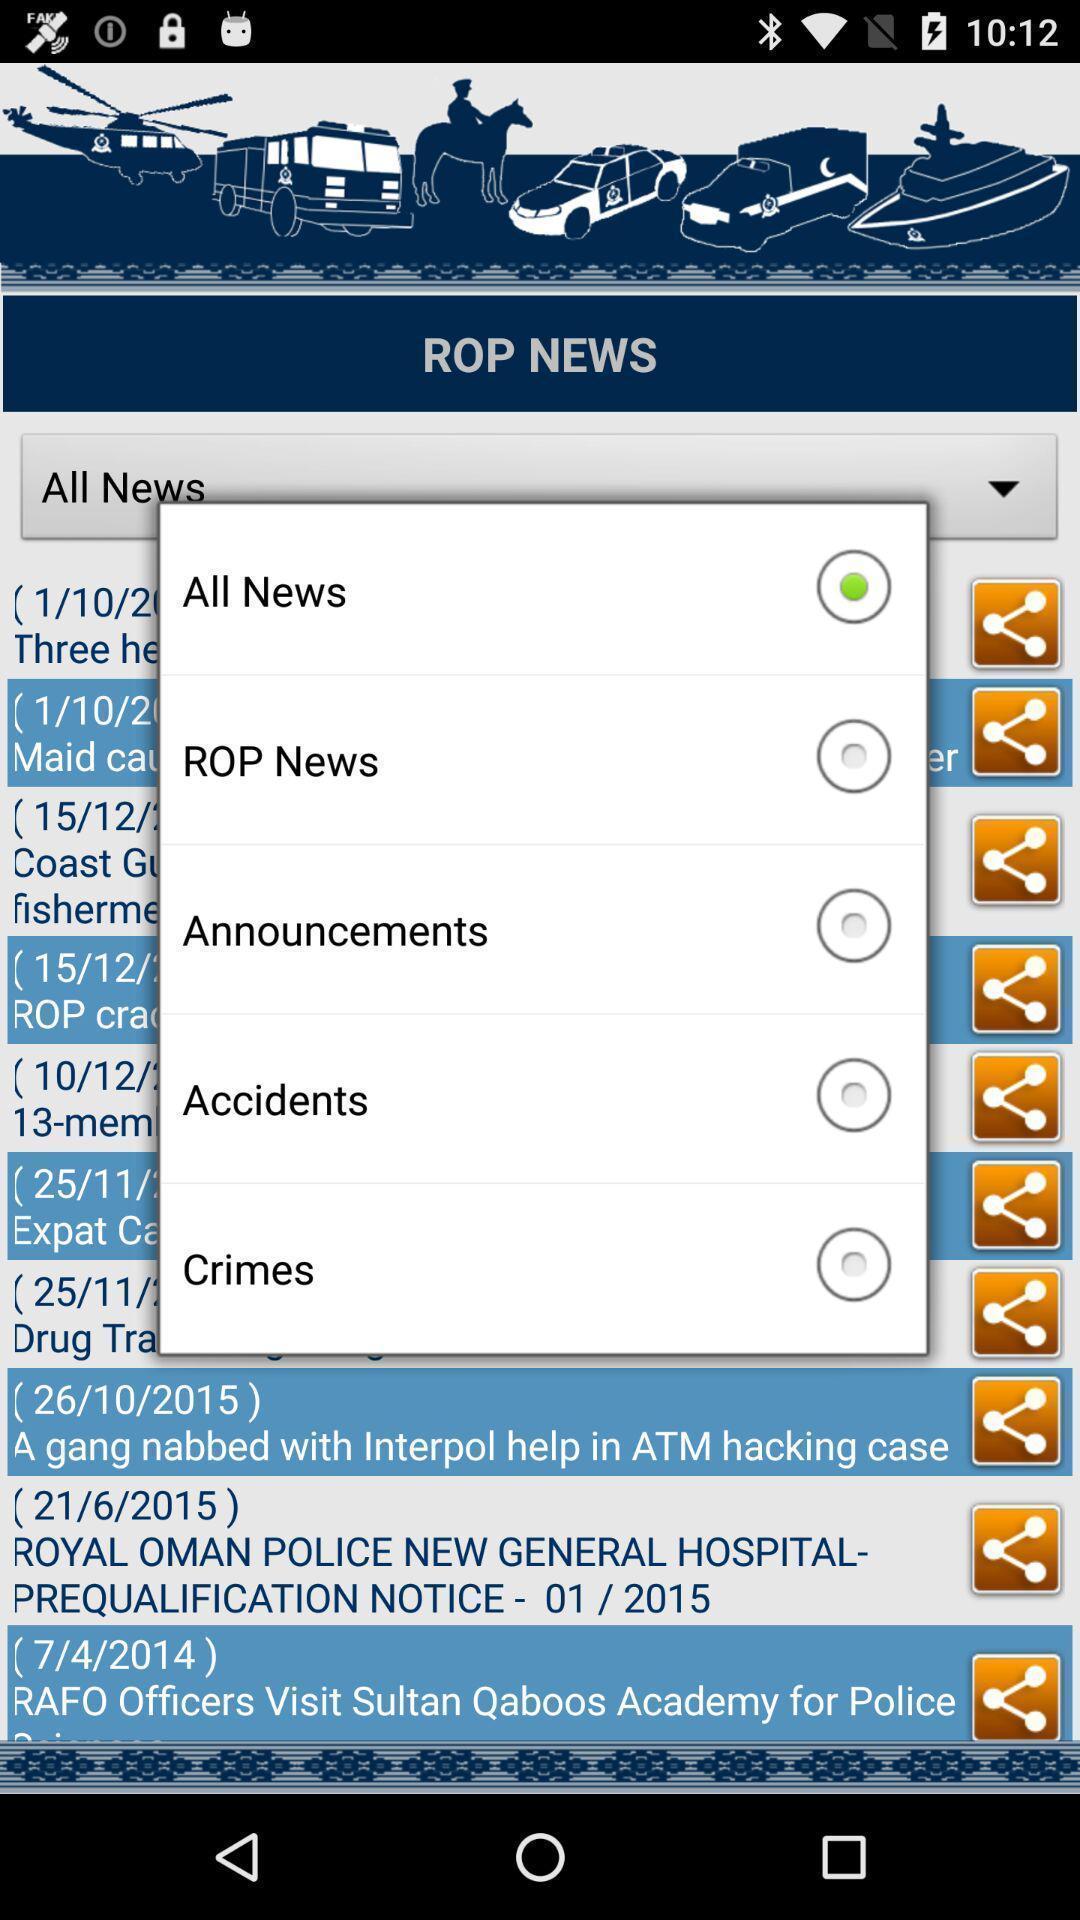Describe this image in words. Pop-up showing various news categories. 